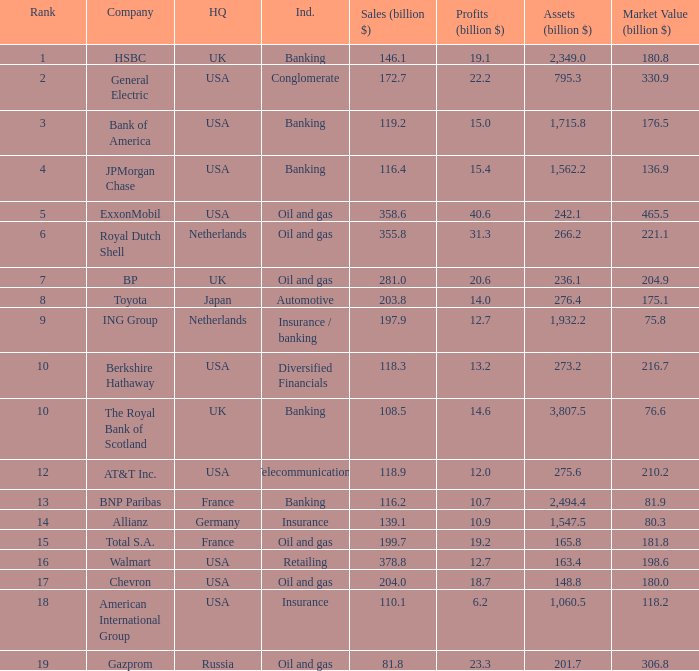What is the amount of profits in billions for companies with a market value of 204.9 billion?  20.6. Could you parse the entire table? {'header': ['Rank', 'Company', 'HQ', 'Ind.', 'Sales (billion $)', 'Profits (billion $)', 'Assets (billion $)', 'Market Value (billion $)'], 'rows': [['1', 'HSBC', 'UK', 'Banking', '146.1', '19.1', '2,349.0', '180.8'], ['2', 'General Electric', 'USA', 'Conglomerate', '172.7', '22.2', '795.3', '330.9'], ['3', 'Bank of America', 'USA', 'Banking', '119.2', '15.0', '1,715.8', '176.5'], ['4', 'JPMorgan Chase', 'USA', 'Banking', '116.4', '15.4', '1,562.2', '136.9'], ['5', 'ExxonMobil', 'USA', 'Oil and gas', '358.6', '40.6', '242.1', '465.5'], ['6', 'Royal Dutch Shell', 'Netherlands', 'Oil and gas', '355.8', '31.3', '266.2', '221.1'], ['7', 'BP', 'UK', 'Oil and gas', '281.0', '20.6', '236.1', '204.9'], ['8', 'Toyota', 'Japan', 'Automotive', '203.8', '14.0', '276.4', '175.1'], ['9', 'ING Group', 'Netherlands', 'Insurance / banking', '197.9', '12.7', '1,932.2', '75.8'], ['10', 'Berkshire Hathaway', 'USA', 'Diversified Financials', '118.3', '13.2', '273.2', '216.7'], ['10', 'The Royal Bank of Scotland', 'UK', 'Banking', '108.5', '14.6', '3,807.5', '76.6'], ['12', 'AT&T Inc.', 'USA', 'Telecommunications', '118.9', '12.0', '275.6', '210.2'], ['13', 'BNP Paribas', 'France', 'Banking', '116.2', '10.7', '2,494.4', '81.9'], ['14', 'Allianz', 'Germany', 'Insurance', '139.1', '10.9', '1,547.5', '80.3'], ['15', 'Total S.A.', 'France', 'Oil and gas', '199.7', '19.2', '165.8', '181.8'], ['16', 'Walmart', 'USA', 'Retailing', '378.8', '12.7', '163.4', '198.6'], ['17', 'Chevron', 'USA', 'Oil and gas', '204.0', '18.7', '148.8', '180.0'], ['18', 'American International Group', 'USA', 'Insurance', '110.1', '6.2', '1,060.5', '118.2'], ['19', 'Gazprom', 'Russia', 'Oil and gas', '81.8', '23.3', '201.7', '306.8']]} 